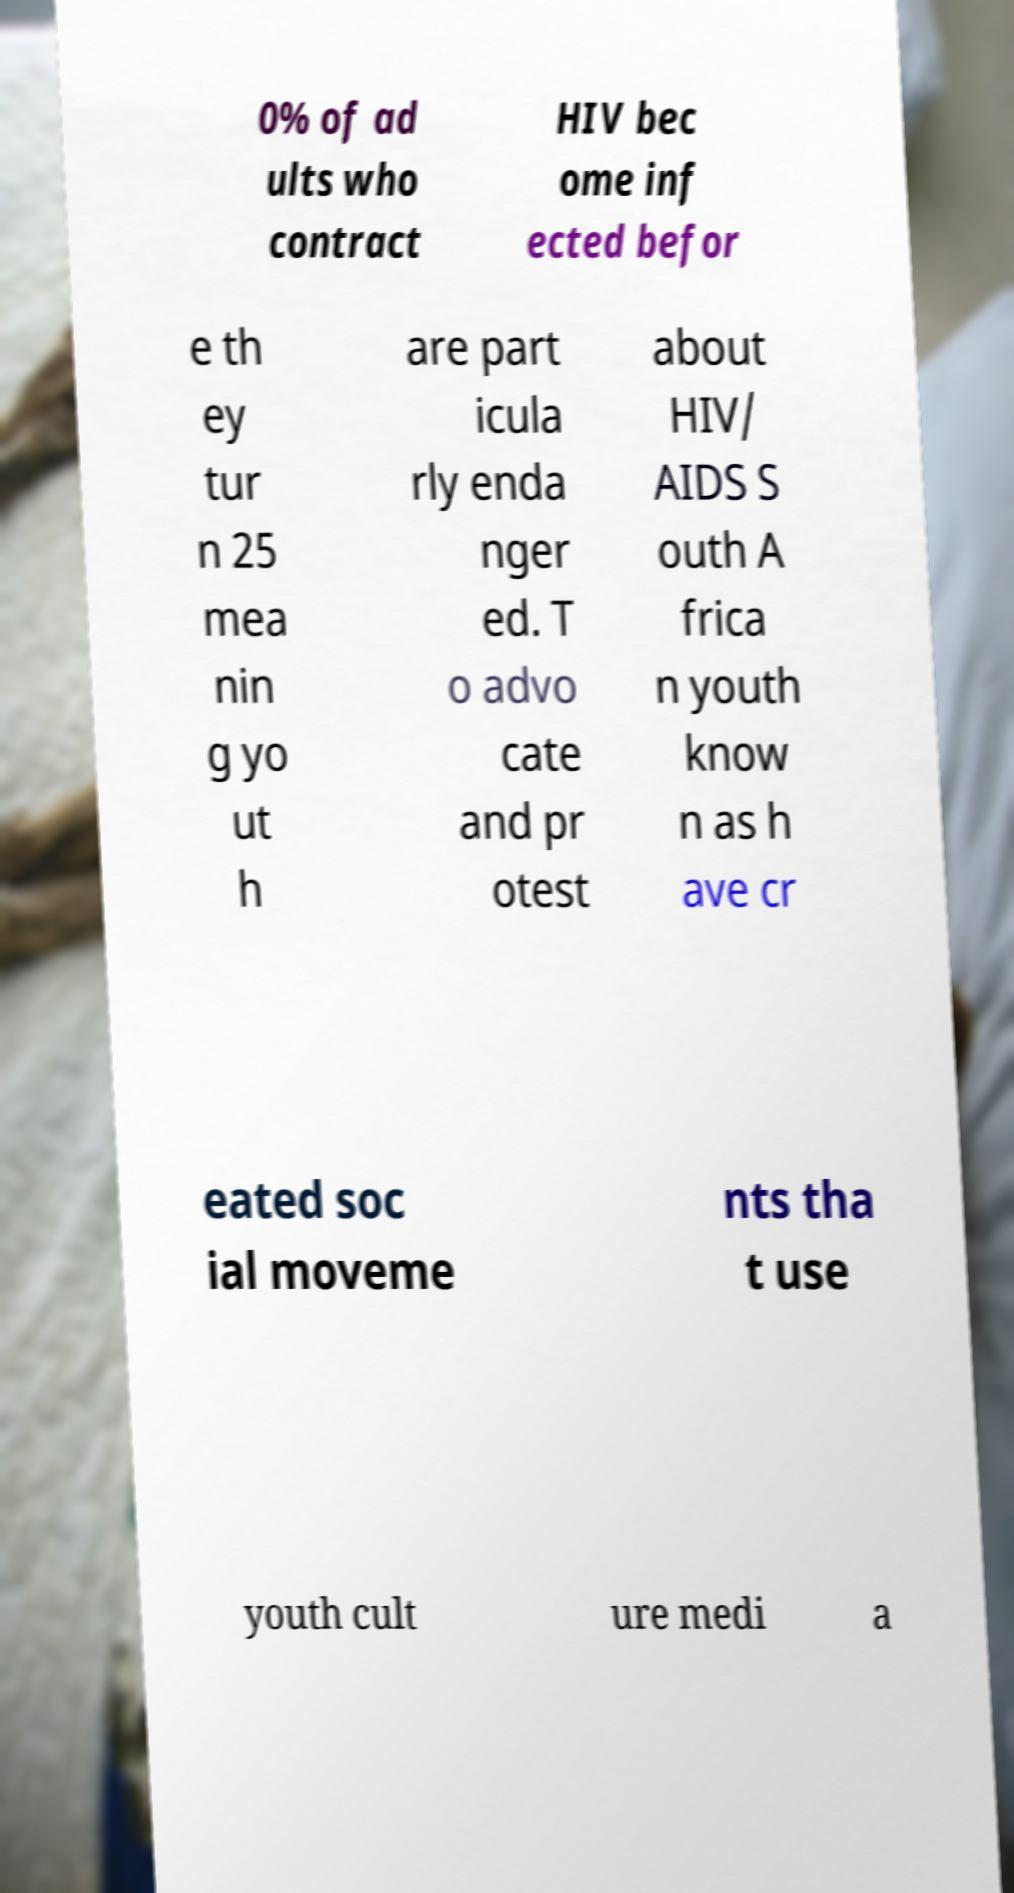Please identify and transcribe the text found in this image. 0% of ad ults who contract HIV bec ome inf ected befor e th ey tur n 25 mea nin g yo ut h are part icula rly enda nger ed. T o advo cate and pr otest about HIV/ AIDS S outh A frica n youth know n as h ave cr eated soc ial moveme nts tha t use youth cult ure medi a 